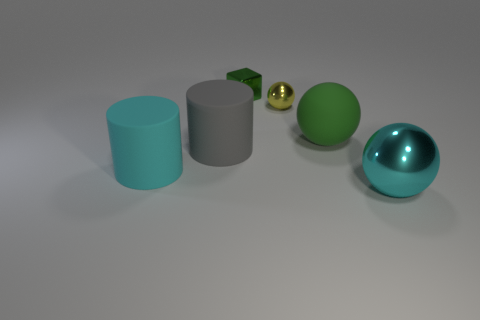How many big objects are either rubber cylinders or gray rubber cylinders?
Your response must be concise. 2. There is a tiny object that is the same color as the big matte sphere; what material is it?
Offer a terse response. Metal. Is the number of small metal cubes less than the number of small cyan cylinders?
Offer a very short reply. No. Do the metallic sphere that is on the left side of the large cyan sphere and the cyan thing that is to the left of the cyan shiny sphere have the same size?
Offer a very short reply. No. How many blue objects are either spheres or tiny matte objects?
Offer a terse response. 0. There is a sphere that is the same color as the metal cube; what size is it?
Your response must be concise. Large. Is the number of cyan metallic spheres greater than the number of green metallic balls?
Offer a terse response. Yes. Do the big matte ball and the small metallic cube have the same color?
Your answer should be compact. Yes. How many things are either cyan metallic objects or large cyan things that are right of the small green shiny object?
Your response must be concise. 1. What number of other objects are the same shape as the yellow metallic thing?
Keep it short and to the point. 2. 